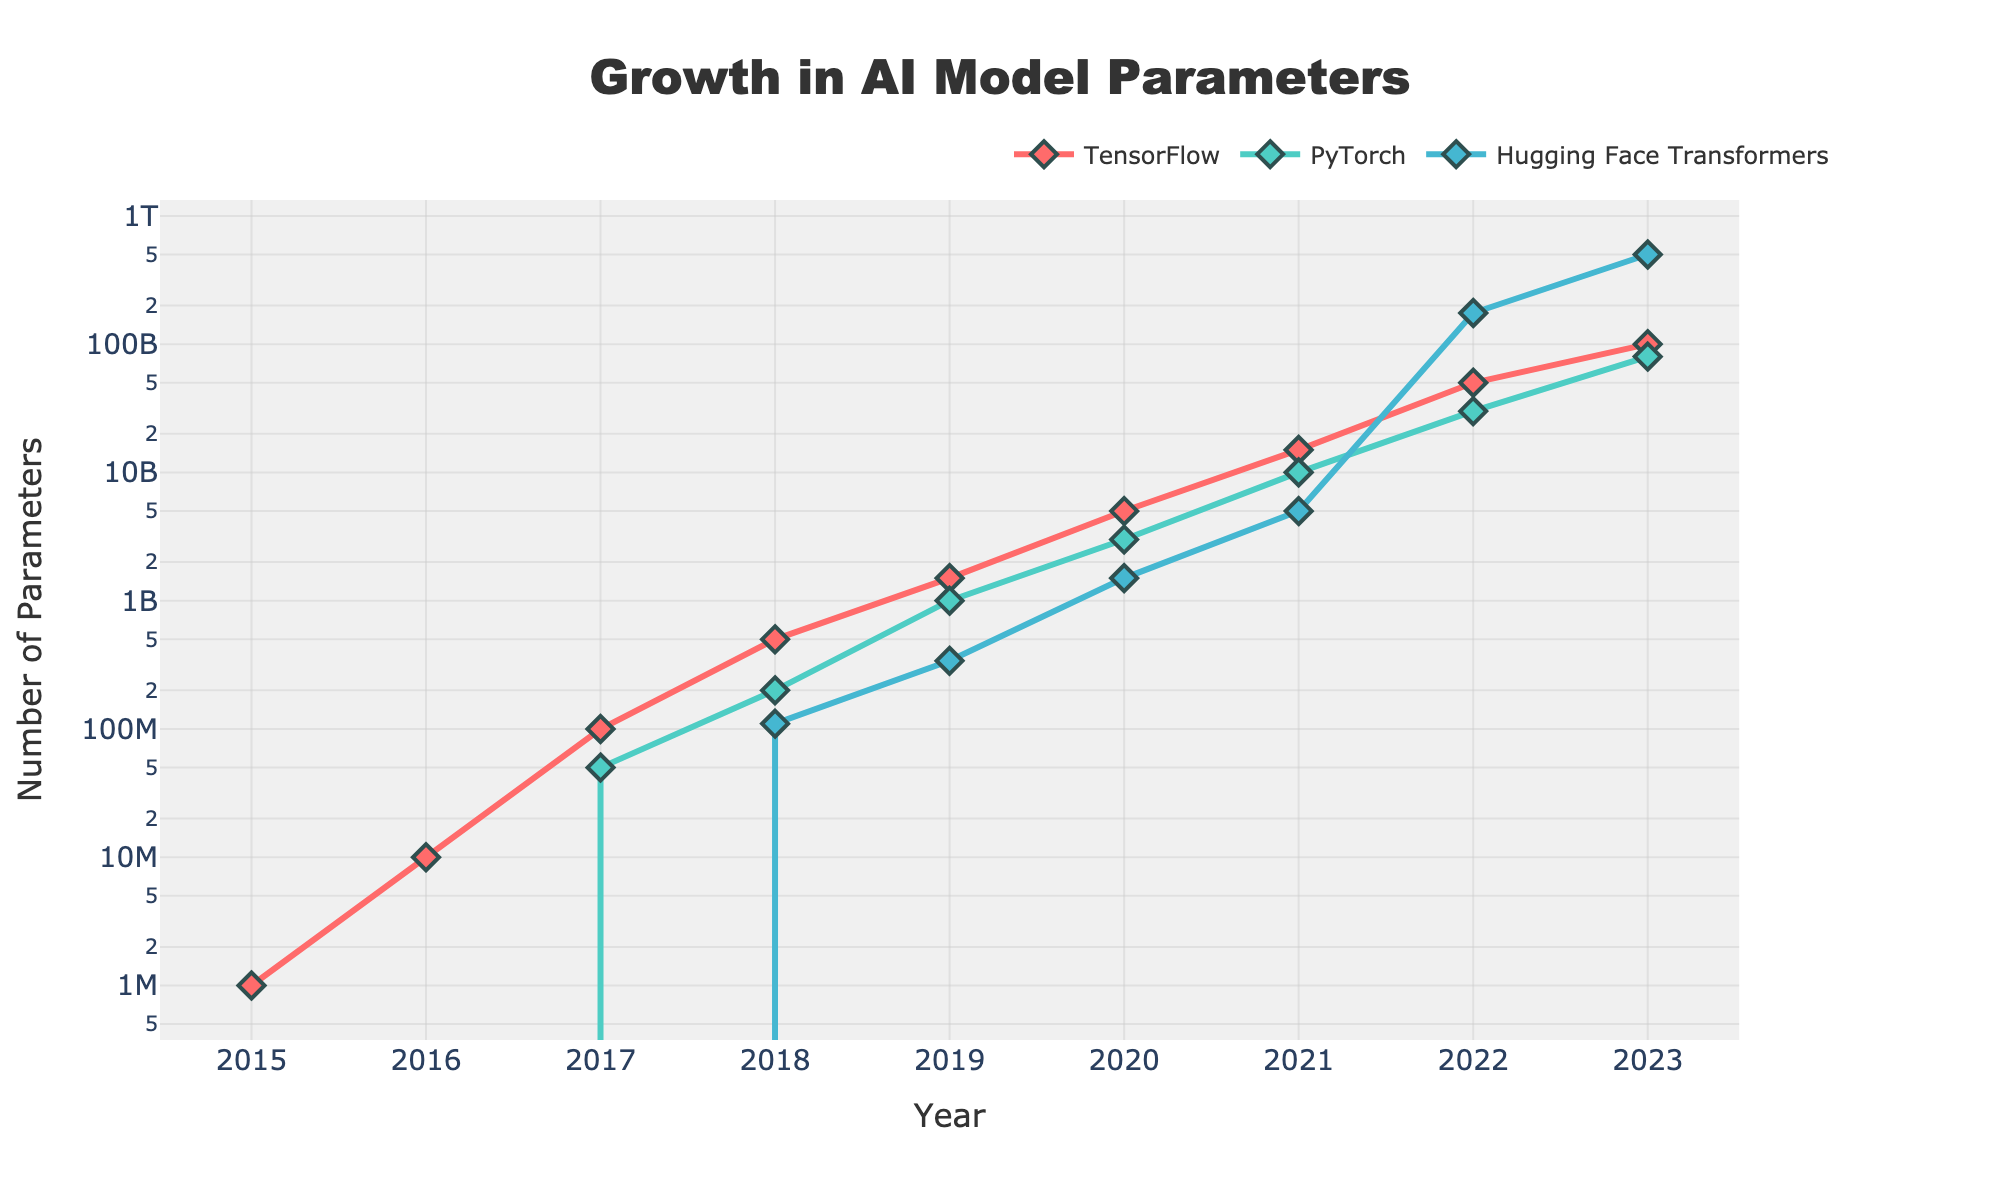What year did Hugging Face Transformers surpass both TensorFlow and PyTorch in terms of model parameters? Observe the plot lines for each framework. Hugging Face Transformers surpassed both TensorFlow and PyTorch in model parameters in 2022.
Answer: 2022 Which framework saw the biggest increase in the number of parameters between 2022 and 2023? Compare the differences in model parameters from 2022 to 2023 for each framework. Hugging Face Transformers increased by 325 billion (from 175 billion to 500 billion), which is the largest.
Answer: Hugging Face Transformers By how many parameters did TensorFlow outgrow PyTorch by 2021? Check the data points for TensorFlow and PyTorch in 2021. TensorFlow had 15 billion parameters, and PyTorch had 10 billion. The difference is 5 billion.
Answer: 5 billion How many more parameters did PyTorch models have in 2020 compared to TensorFlow models in 2018? Look at the chart for the number of parameters in PyTorch in 2020 and TensorFlow in 2018. PyTorch in 2020 had 3 billion, and TensorFlow in 2018 had 500 million. The difference is 2.5 billion.
Answer: 2.5 billion What was the growth rate of TensorFlow model parameters from 2016 to 2017? Calculate the growth between the number of parameters in 2016 (10 million) and 2017 (100 million). The growth rate can be calculated as (100m - 10m) / 10m = 9, or 900%.
Answer: 900% Which two frameworks had the biggest visual gap in parameters in 2023? On the plot, visually compare the gaps between the lines representing each framework in 2023. Hugging Face Transformers and TensorFlow exhibit the largest gap.
Answer: Hugging Face Transformers and TensorFlow Considering all years, which year had the smallest difference in model parameters between PyTorch and Hugging Face Transformers? Analyze the distances between the PyTorch and Hugging Face Transformers lines year by year. The smallest difference observed graphically is in 2018.
Answer: 2018 What is the color used to represent TensorFlow in the plot? Look at the legend in the plot to determine the color associated with TensorFlow. TensorFlow is depicted with a red color.
Answer: Red 